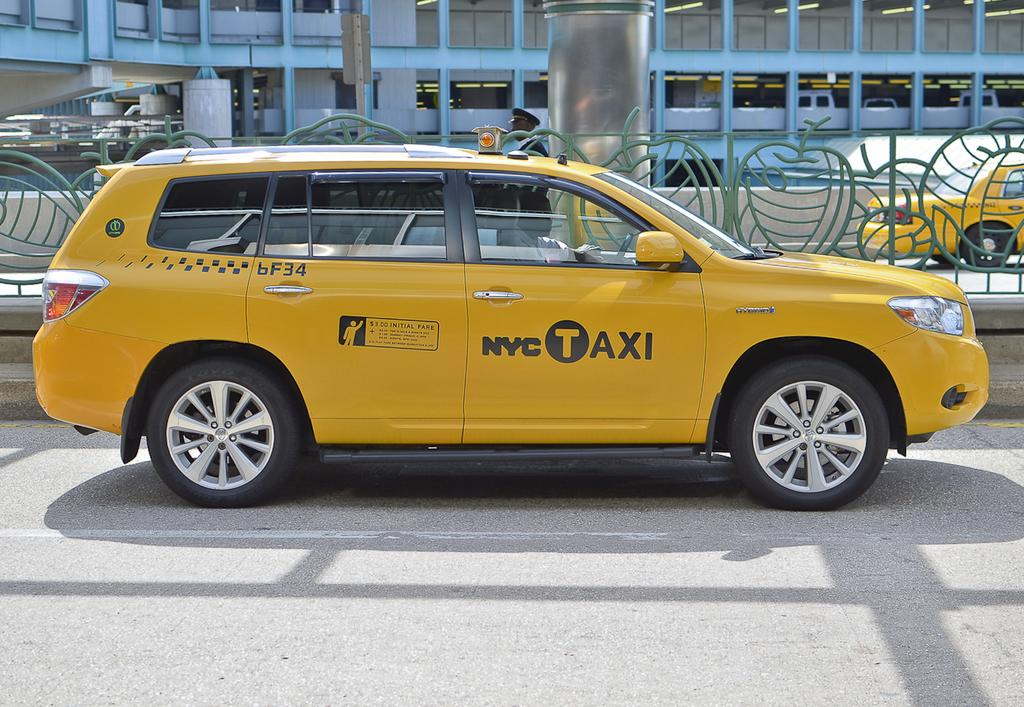<image>
Summarize the visual content of the image. A NYC Taxi charges $3.00 for the initial fare. 